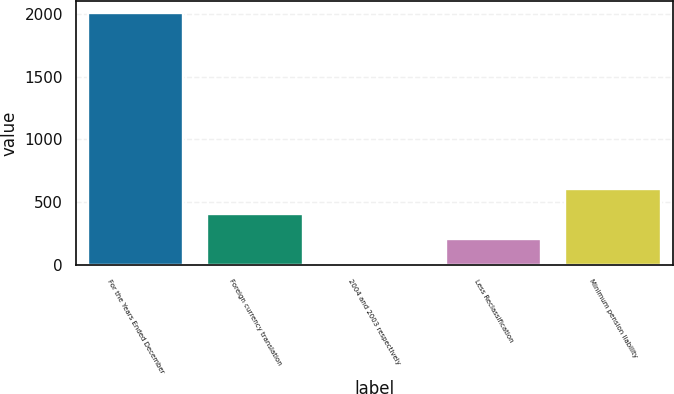Convert chart. <chart><loc_0><loc_0><loc_500><loc_500><bar_chart><fcel>For the Years Ended December<fcel>Foreign currency translation<fcel>2004 and 2003 respectively<fcel>Less Reclassification<fcel>Minimum pension liability<nl><fcel>2004<fcel>407.2<fcel>8<fcel>207.6<fcel>606.8<nl></chart> 